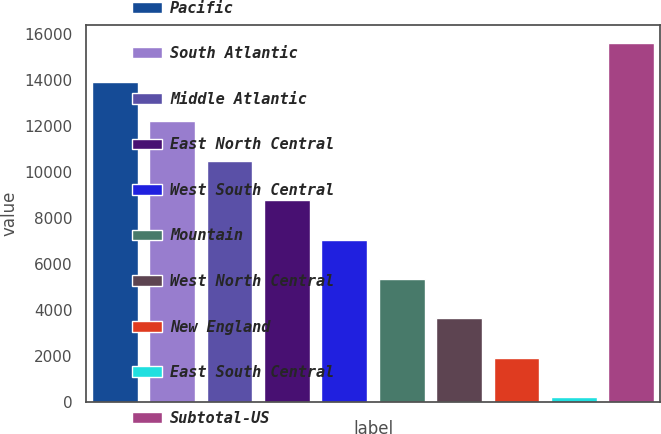<chart> <loc_0><loc_0><loc_500><loc_500><bar_chart><fcel>Pacific<fcel>South Atlantic<fcel>Middle Atlantic<fcel>East North Central<fcel>West South Central<fcel>Mountain<fcel>West North Central<fcel>New England<fcel>East South Central<fcel>Subtotal-US<nl><fcel>13924<fcel>12207.5<fcel>10491<fcel>8774.5<fcel>7058<fcel>5341.5<fcel>3625<fcel>1908.5<fcel>192<fcel>15640.5<nl></chart> 